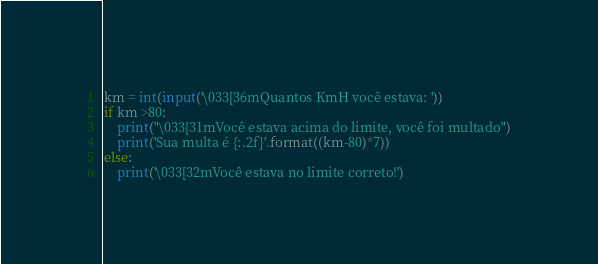Convert code to text. <code><loc_0><loc_0><loc_500><loc_500><_Python_>km = int(input('\033[36mQuantos KmH você estava: '))
if km >80:
    print("\033[31mVocê estava acima do limite, você foi multado")
    print('Sua multa é {:.2f}'.format((km-80)*7))
else:
    print('\033[32mVocê estava no limite correto!')
</code> 